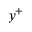<formula> <loc_0><loc_0><loc_500><loc_500>y ^ { + }</formula> 